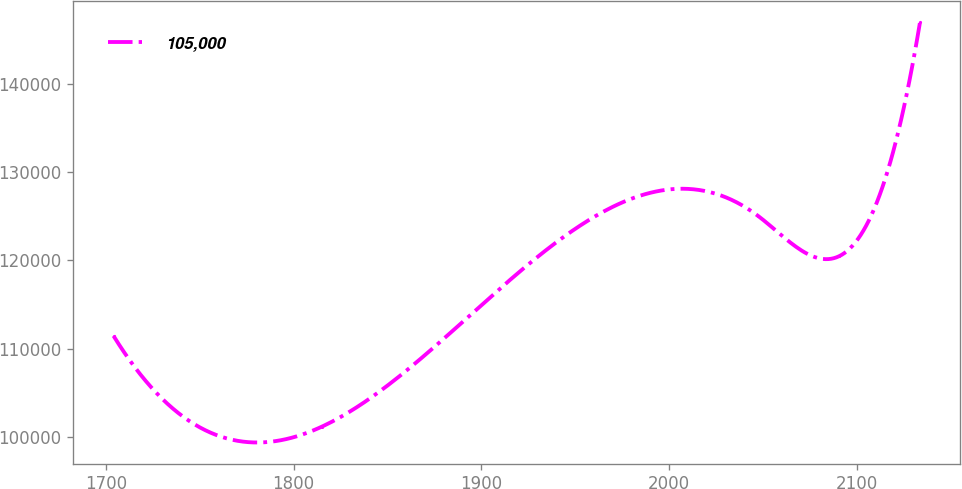Convert chart. <chart><loc_0><loc_0><loc_500><loc_500><line_chart><ecel><fcel>105,000<nl><fcel>1704.08<fcel>111455<nl><fcel>1814.91<fcel>101162<nl><fcel>2047.25<fcel>125043<nl><fcel>2090.2<fcel>120456<nl><fcel>2133.53<fcel>147036<nl></chart> 